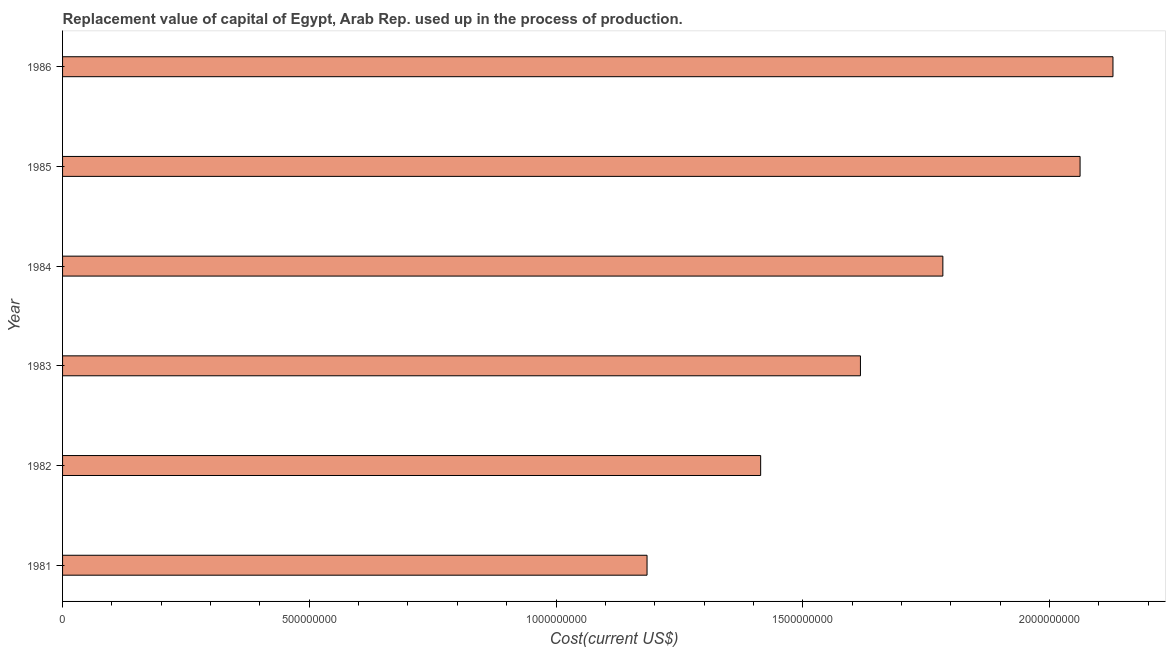Does the graph contain grids?
Your answer should be very brief. No. What is the title of the graph?
Make the answer very short. Replacement value of capital of Egypt, Arab Rep. used up in the process of production. What is the label or title of the X-axis?
Make the answer very short. Cost(current US$). What is the consumption of fixed capital in 1983?
Give a very brief answer. 1.62e+09. Across all years, what is the maximum consumption of fixed capital?
Your answer should be compact. 2.13e+09. Across all years, what is the minimum consumption of fixed capital?
Your response must be concise. 1.18e+09. What is the sum of the consumption of fixed capital?
Provide a succinct answer. 1.02e+1. What is the difference between the consumption of fixed capital in 1985 and 1986?
Provide a succinct answer. -6.66e+07. What is the average consumption of fixed capital per year?
Make the answer very short. 1.70e+09. What is the median consumption of fixed capital?
Provide a succinct answer. 1.70e+09. In how many years, is the consumption of fixed capital greater than 1500000000 US$?
Offer a very short reply. 4. Do a majority of the years between 1986 and 1983 (inclusive) have consumption of fixed capital greater than 1300000000 US$?
Provide a succinct answer. Yes. What is the ratio of the consumption of fixed capital in 1981 to that in 1985?
Give a very brief answer. 0.57. Is the consumption of fixed capital in 1981 less than that in 1984?
Provide a short and direct response. Yes. Is the difference between the consumption of fixed capital in 1984 and 1986 greater than the difference between any two years?
Ensure brevity in your answer.  No. What is the difference between the highest and the second highest consumption of fixed capital?
Ensure brevity in your answer.  6.66e+07. What is the difference between the highest and the lowest consumption of fixed capital?
Your answer should be compact. 9.44e+08. In how many years, is the consumption of fixed capital greater than the average consumption of fixed capital taken over all years?
Your response must be concise. 3. Are all the bars in the graph horizontal?
Provide a short and direct response. Yes. How many years are there in the graph?
Offer a terse response. 6. What is the difference between two consecutive major ticks on the X-axis?
Offer a very short reply. 5.00e+08. What is the Cost(current US$) of 1981?
Make the answer very short. 1.18e+09. What is the Cost(current US$) in 1982?
Ensure brevity in your answer.  1.41e+09. What is the Cost(current US$) in 1983?
Your answer should be compact. 1.62e+09. What is the Cost(current US$) of 1984?
Your answer should be compact. 1.78e+09. What is the Cost(current US$) in 1985?
Ensure brevity in your answer.  2.06e+09. What is the Cost(current US$) in 1986?
Offer a terse response. 2.13e+09. What is the difference between the Cost(current US$) in 1981 and 1982?
Make the answer very short. -2.30e+08. What is the difference between the Cost(current US$) in 1981 and 1983?
Make the answer very short. -4.32e+08. What is the difference between the Cost(current US$) in 1981 and 1984?
Make the answer very short. -5.99e+08. What is the difference between the Cost(current US$) in 1981 and 1985?
Your response must be concise. -8.78e+08. What is the difference between the Cost(current US$) in 1981 and 1986?
Keep it short and to the point. -9.44e+08. What is the difference between the Cost(current US$) in 1982 and 1983?
Offer a very short reply. -2.02e+08. What is the difference between the Cost(current US$) in 1982 and 1984?
Offer a terse response. -3.69e+08. What is the difference between the Cost(current US$) in 1982 and 1985?
Make the answer very short. -6.47e+08. What is the difference between the Cost(current US$) in 1982 and 1986?
Ensure brevity in your answer.  -7.14e+08. What is the difference between the Cost(current US$) in 1983 and 1984?
Give a very brief answer. -1.67e+08. What is the difference between the Cost(current US$) in 1983 and 1985?
Keep it short and to the point. -4.45e+08. What is the difference between the Cost(current US$) in 1983 and 1986?
Offer a very short reply. -5.12e+08. What is the difference between the Cost(current US$) in 1984 and 1985?
Provide a short and direct response. -2.78e+08. What is the difference between the Cost(current US$) in 1984 and 1986?
Keep it short and to the point. -3.45e+08. What is the difference between the Cost(current US$) in 1985 and 1986?
Offer a terse response. -6.66e+07. What is the ratio of the Cost(current US$) in 1981 to that in 1982?
Your answer should be very brief. 0.84. What is the ratio of the Cost(current US$) in 1981 to that in 1983?
Offer a very short reply. 0.73. What is the ratio of the Cost(current US$) in 1981 to that in 1984?
Give a very brief answer. 0.66. What is the ratio of the Cost(current US$) in 1981 to that in 1985?
Ensure brevity in your answer.  0.57. What is the ratio of the Cost(current US$) in 1981 to that in 1986?
Your response must be concise. 0.56. What is the ratio of the Cost(current US$) in 1982 to that in 1984?
Keep it short and to the point. 0.79. What is the ratio of the Cost(current US$) in 1982 to that in 1985?
Your answer should be very brief. 0.69. What is the ratio of the Cost(current US$) in 1982 to that in 1986?
Your answer should be very brief. 0.67. What is the ratio of the Cost(current US$) in 1983 to that in 1984?
Your answer should be compact. 0.91. What is the ratio of the Cost(current US$) in 1983 to that in 1985?
Give a very brief answer. 0.78. What is the ratio of the Cost(current US$) in 1983 to that in 1986?
Your answer should be very brief. 0.76. What is the ratio of the Cost(current US$) in 1984 to that in 1985?
Provide a succinct answer. 0.86. What is the ratio of the Cost(current US$) in 1984 to that in 1986?
Provide a short and direct response. 0.84. What is the ratio of the Cost(current US$) in 1985 to that in 1986?
Ensure brevity in your answer.  0.97. 